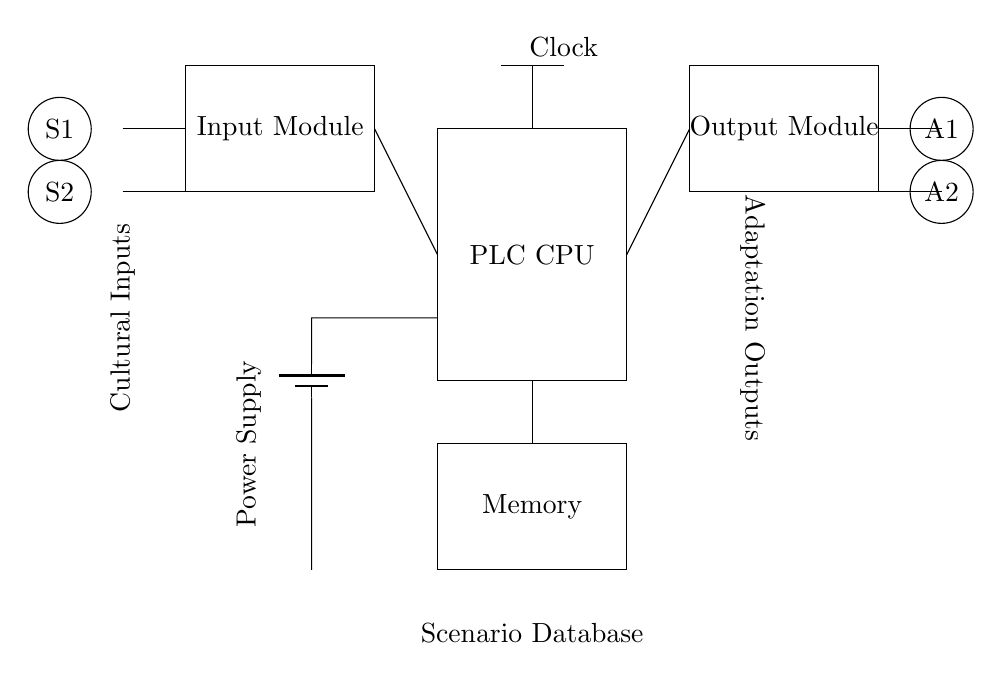What is the main component labeled in the center of the circuit? The central component labeled in the circuit is the PLC CPU, which indicates it is the main processing unit in the programmable logic controller setup.
Answer: PLC CPU What do the circles on the left side represent? The circles on the left side represent sensors S1 and S2, which serve as input devices to detect cultural inputs in the system.
Answer: Sensors How many modules are present in this circuit? There are three modules: the input module, output module, and memory module, indicating multiple functional elements in the circuit.
Answer: Three What is the role of the component labeled as 'Power Supply'? The power supply is responsible for providing the necessary electrical energy to the circuit, allowing all components to operate.
Answer: Providing energy Which connections are made to the output module? Connections from the PLC CPU are made to the output module, indicating a flow of processed data to the actuators.
Answer: Connections from PLC CPU How does the clock interact with the PLC CPU in this circuit? The clock provides timing signals to the PLC CPU, ensuring that operations are synchronized and occur at precise intervals in the control process.
Answer: Timing signals What is indicated by the labels 'Cultural Inputs' and 'Adaptation Outputs'? 'Cultural Inputs' indicates the data received from sensors, while 'Adaptation Outputs' shows the responses sent to the actuators based on processed input.
Answer: Input and output data 